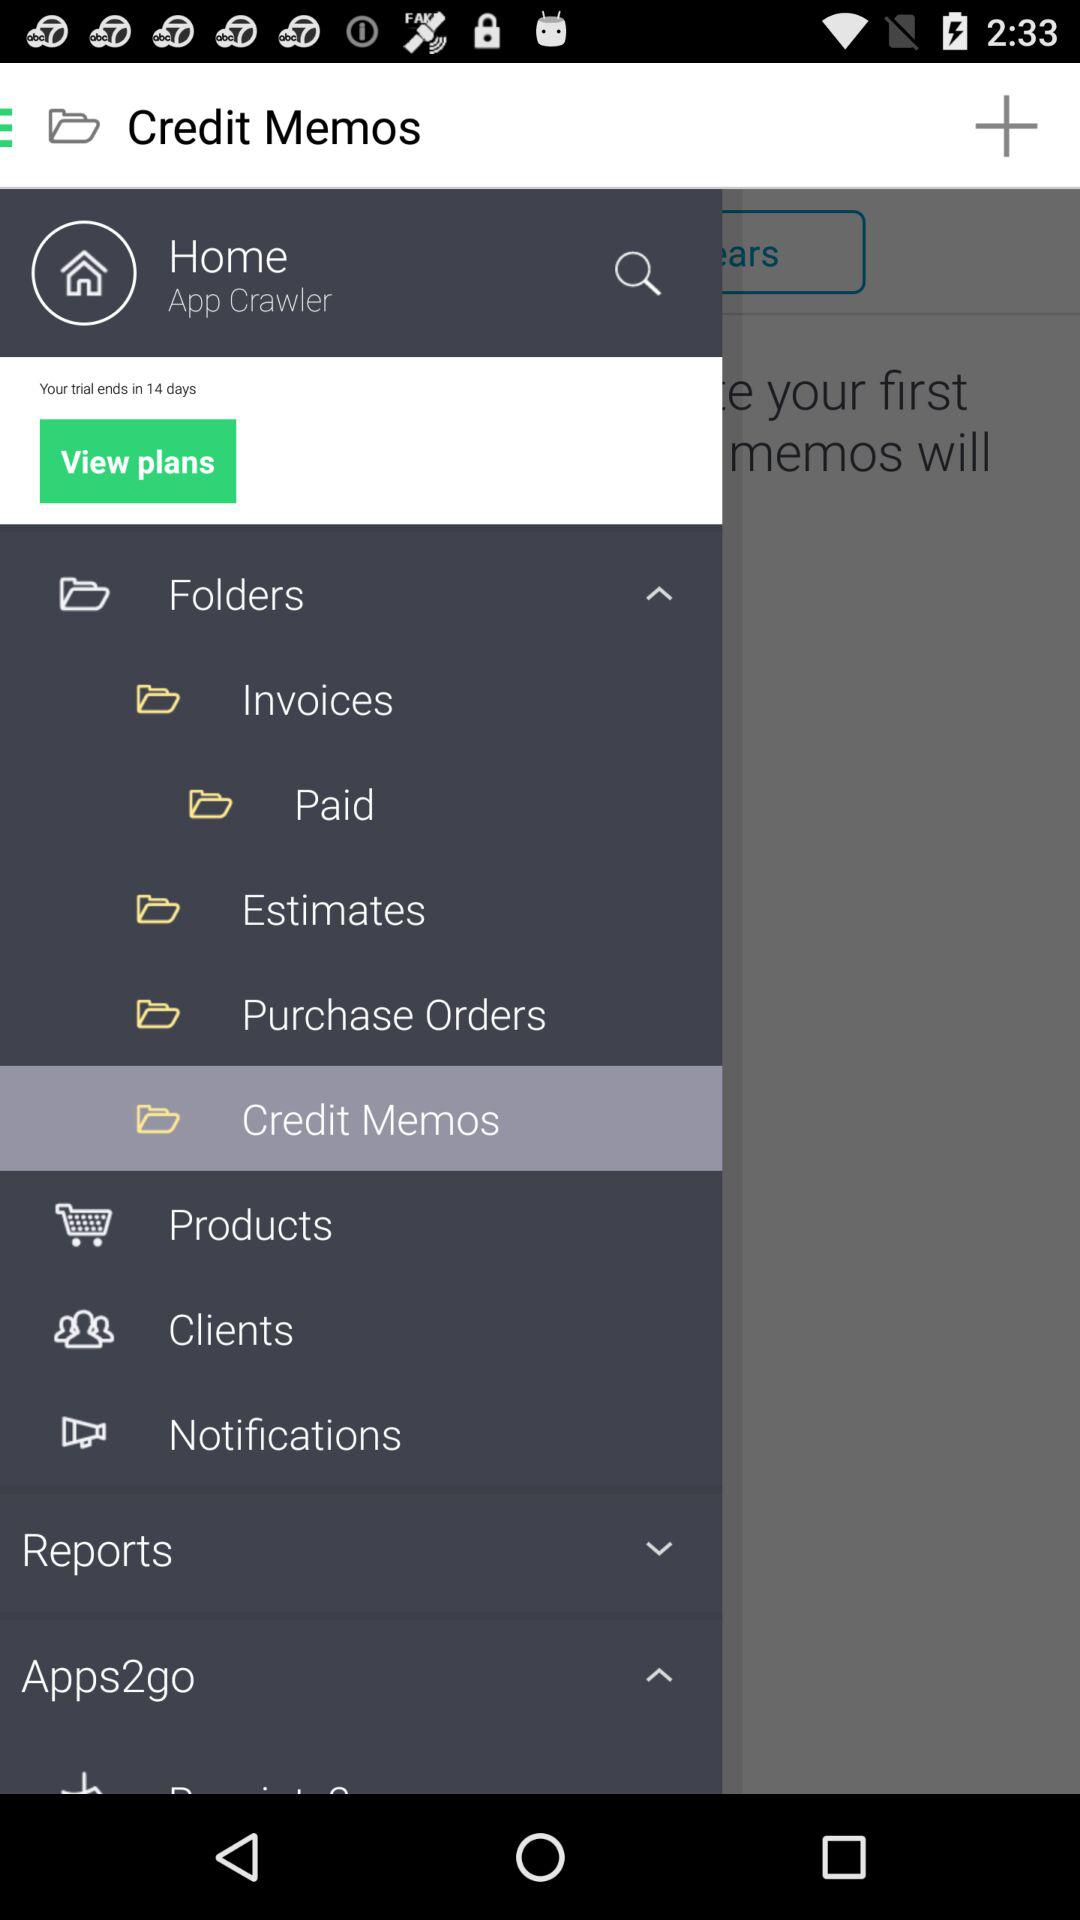What is the user name? The user name is "App Crawler". 